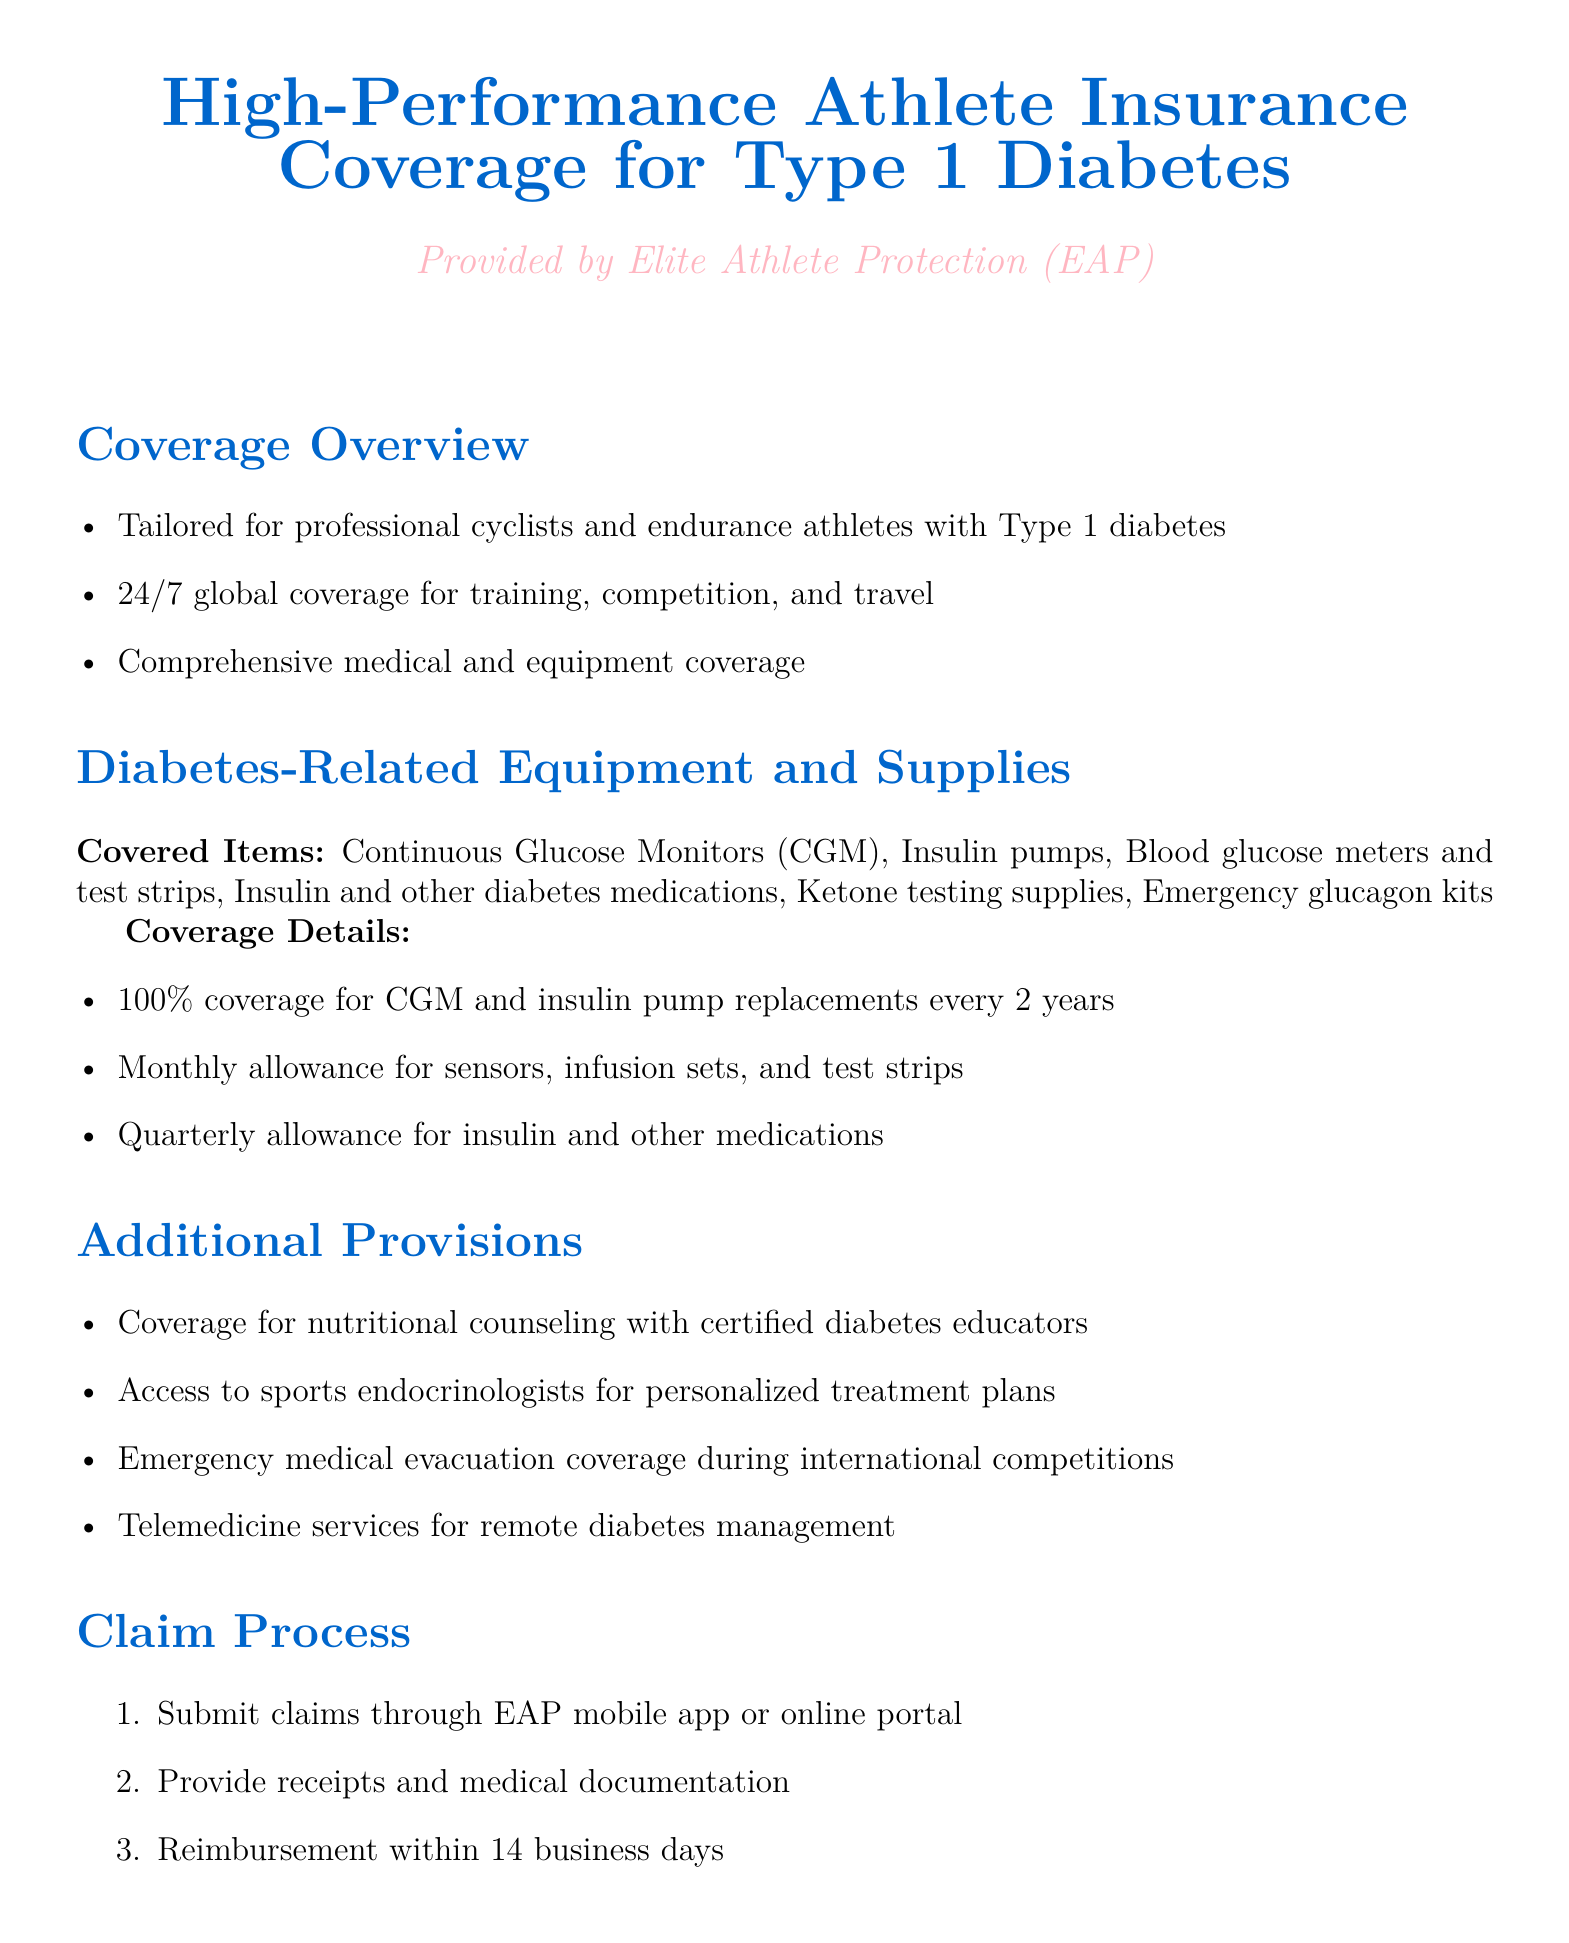What is the name of the insurance provider? The policy document states the insurance provider is Elite Athlete Protection (EAP).
Answer: Elite Athlete Protection (EAP) What types of diabetes-related equipment are covered? The document lists covered items including CGM, insulin pumps, blood glucose meters, and others.
Answer: Continuous Glucose Monitors (CGM), Insulin pumps, Blood glucose meters and test strips, Insulin and other diabetes medications, Ketone testing supplies, Emergency glucagon kits How often are CGM and insulin pump replacements covered? The document specifies that replacements for CGMs and insulin pumps are covered every 2 years.
Answer: every 2 years What allows for reimbursement of claims? The claim process involves submitting receipts and medical documentation.
Answer: Receipts and medical documentation What is excluded from coverage? The policy excludes pre-existing complications unrelated to Type 1 diabetes.
Answer: Pre-existing complications unrelated to Type 1 diabetes What type of counseling is covered? The policy includes coverage for nutritional counseling.
Answer: Nutritional counseling How quickly can reimbursements be expected? The document states reimbursement is made within 14 business days.
Answer: 14 business days Is telemedicine service available for diabetes management? The document mentions telemedicine services for remote diabetes management.
Answer: Yes What is the monthly allowance for sensors and test strips? Monthly allowances for sensors, infusion sets, and test strips are detailed, but specific amounts aren't provided.
Answer: Monthly allowance 